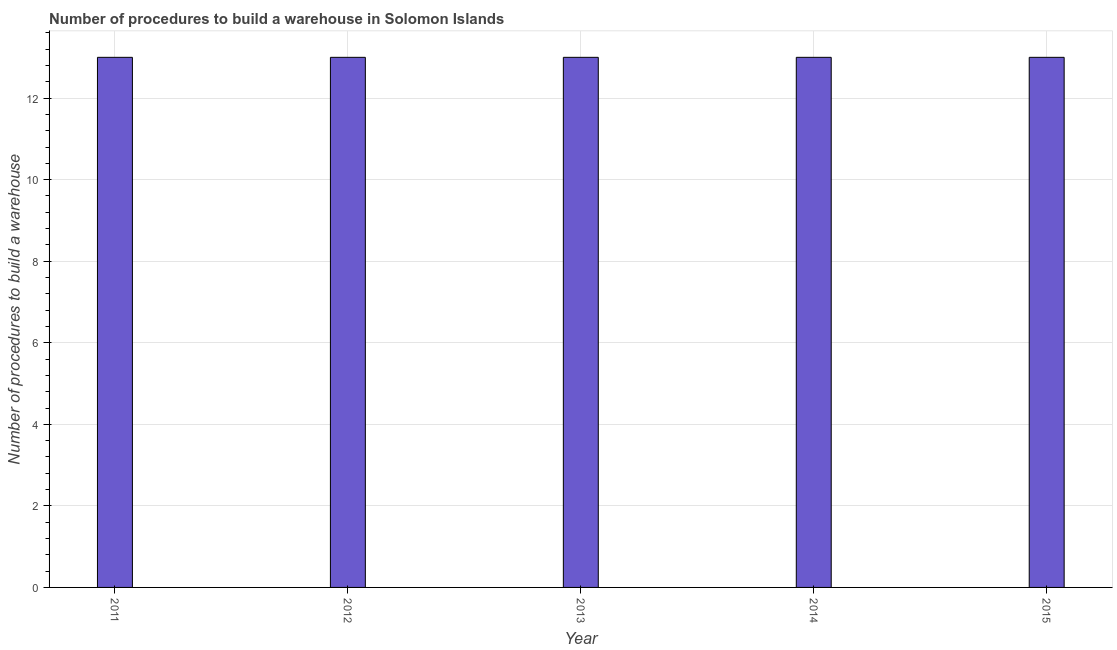Does the graph contain any zero values?
Offer a terse response. No. What is the title of the graph?
Keep it short and to the point. Number of procedures to build a warehouse in Solomon Islands. What is the label or title of the Y-axis?
Provide a short and direct response. Number of procedures to build a warehouse. In which year was the number of procedures to build a warehouse maximum?
Ensure brevity in your answer.  2011. What is the difference between the number of procedures to build a warehouse in 2013 and 2014?
Ensure brevity in your answer.  0. What is the median number of procedures to build a warehouse?
Make the answer very short. 13. What is the ratio of the number of procedures to build a warehouse in 2012 to that in 2014?
Give a very brief answer. 1. Is the number of procedures to build a warehouse in 2012 less than that in 2015?
Keep it short and to the point. No. What is the difference between the highest and the second highest number of procedures to build a warehouse?
Your response must be concise. 0. Is the sum of the number of procedures to build a warehouse in 2012 and 2013 greater than the maximum number of procedures to build a warehouse across all years?
Give a very brief answer. Yes. What is the Number of procedures to build a warehouse of 2012?
Keep it short and to the point. 13. What is the Number of procedures to build a warehouse in 2014?
Your answer should be compact. 13. What is the Number of procedures to build a warehouse of 2015?
Your answer should be very brief. 13. What is the difference between the Number of procedures to build a warehouse in 2011 and 2012?
Make the answer very short. 0. What is the difference between the Number of procedures to build a warehouse in 2011 and 2015?
Provide a succinct answer. 0. What is the difference between the Number of procedures to build a warehouse in 2012 and 2013?
Make the answer very short. 0. What is the difference between the Number of procedures to build a warehouse in 2013 and 2014?
Provide a short and direct response. 0. What is the ratio of the Number of procedures to build a warehouse in 2011 to that in 2013?
Provide a succinct answer. 1. What is the ratio of the Number of procedures to build a warehouse in 2013 to that in 2014?
Provide a succinct answer. 1. What is the ratio of the Number of procedures to build a warehouse in 2014 to that in 2015?
Offer a very short reply. 1. 